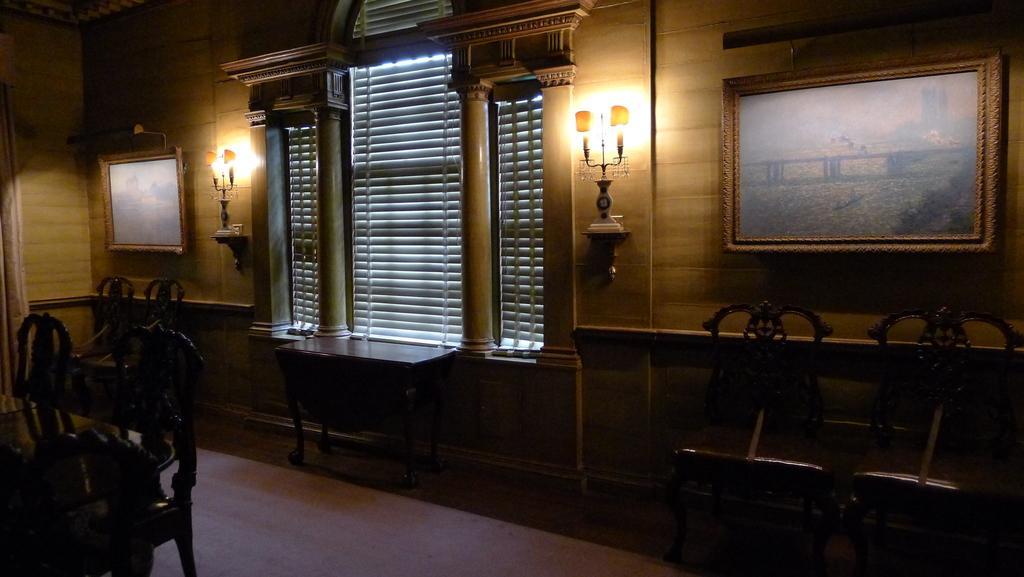Could you give a brief overview of what you see in this image? In the image we can see there is a window and beside it on the wall there are two lightings and there are two photo frames on the wall and there is a dining table and there are chairs and table and the image is little dark. 